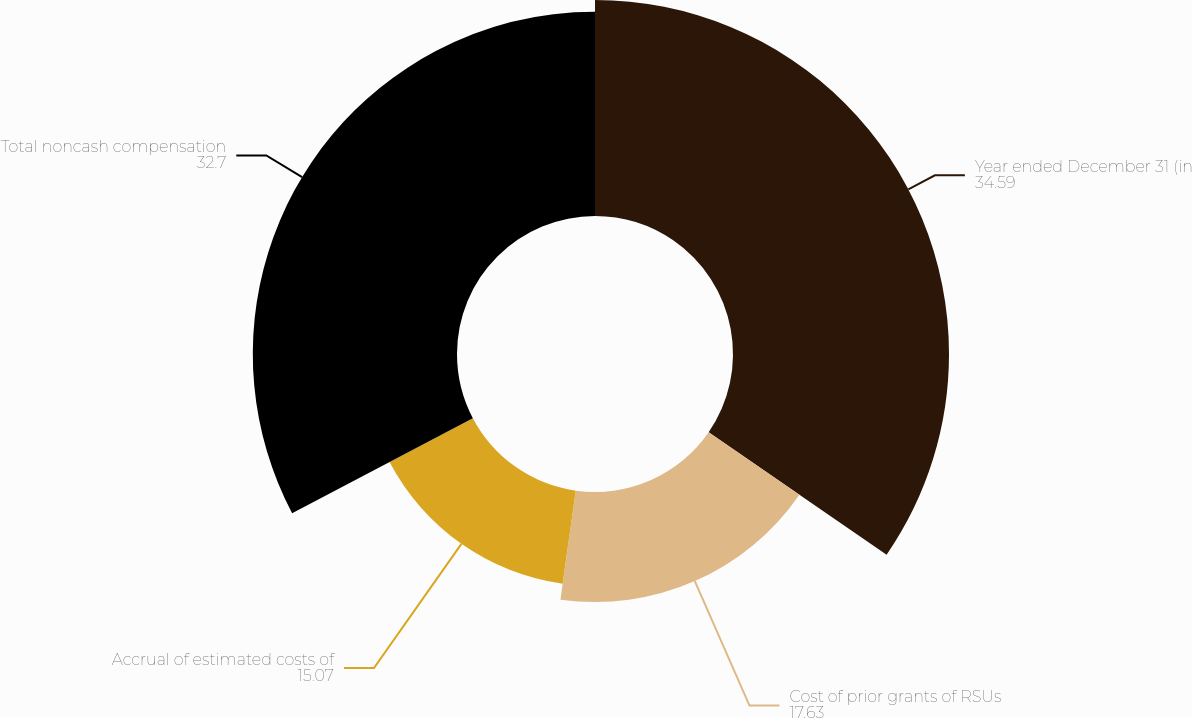<chart> <loc_0><loc_0><loc_500><loc_500><pie_chart><fcel>Year ended December 31 (in<fcel>Cost of prior grants of RSUs<fcel>Accrual of estimated costs of<fcel>Total noncash compensation<nl><fcel>34.59%<fcel>17.63%<fcel>15.07%<fcel>32.7%<nl></chart> 